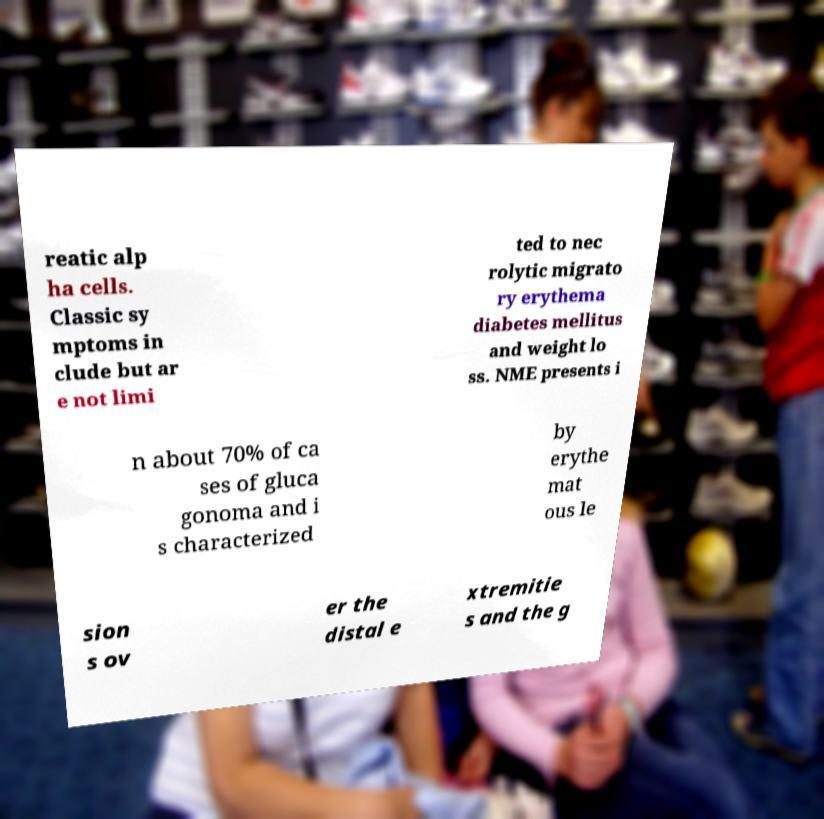Please read and relay the text visible in this image. What does it say? reatic alp ha cells. Classic sy mptoms in clude but ar e not limi ted to nec rolytic migrato ry erythema diabetes mellitus and weight lo ss. NME presents i n about 70% of ca ses of gluca gonoma and i s characterized by erythe mat ous le sion s ov er the distal e xtremitie s and the g 